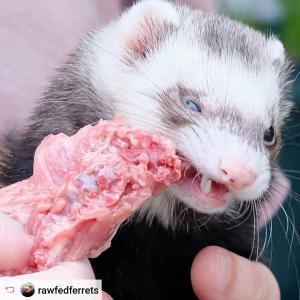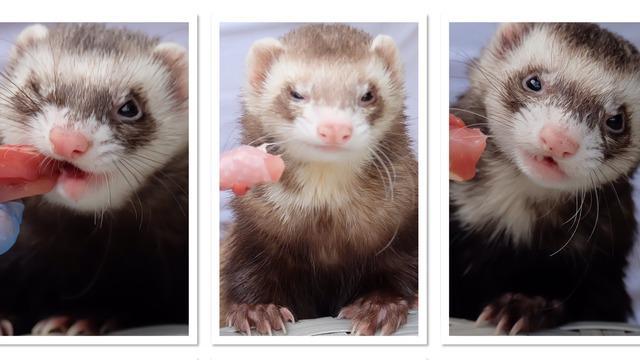The first image is the image on the left, the second image is the image on the right. For the images displayed, is the sentence "Someone is offering a ferret a piece of raw meat in at least one image." factually correct? Answer yes or no. Yes. The first image is the image on the left, the second image is the image on the right. Given the left and right images, does the statement "The left and right image contains the same number of ferrits with at least one person hand in one image." hold true? Answer yes or no. No. 